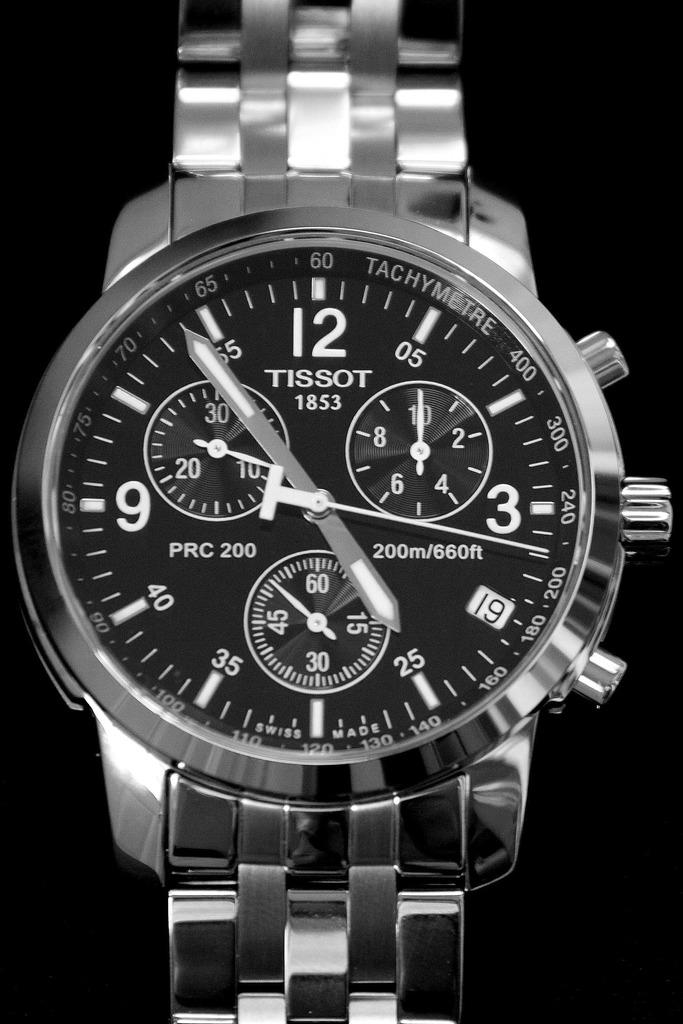What kind of watch is that?
Your response must be concise. Tissot. When was this watch company stared?
Your answer should be compact. 1853. 